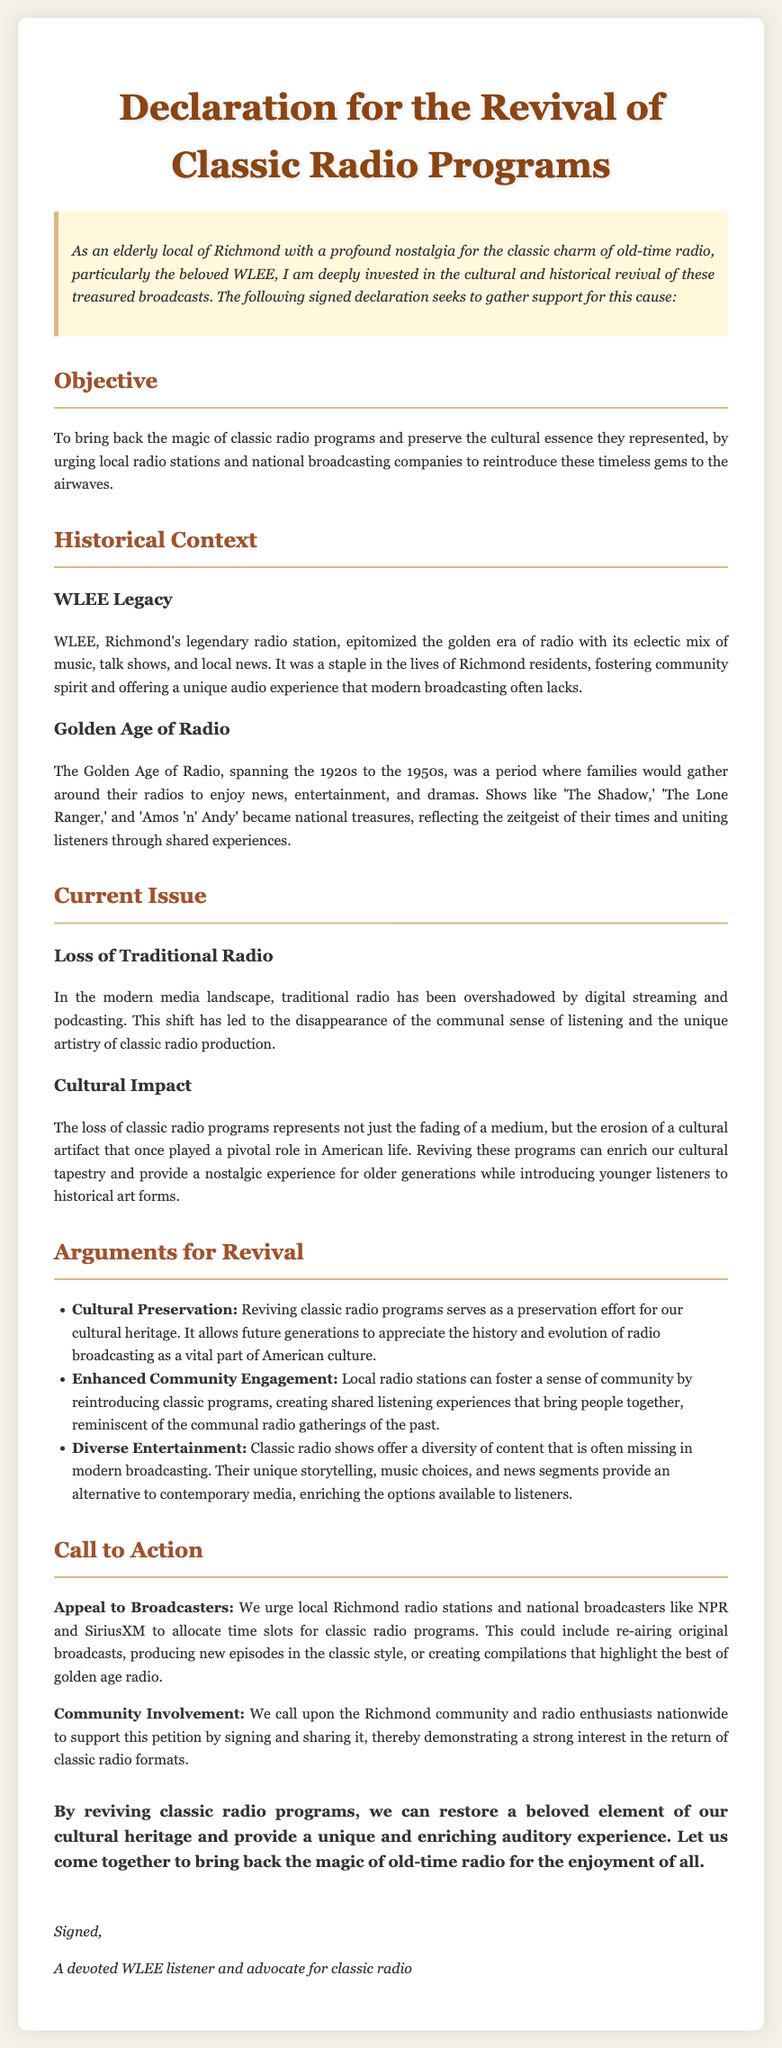What is the title of the document? The title of the document is presented at the top in a prominent format.
Answer: Declaration for the Revival of Classic Radio Programs Who is the intended audience for the call to action? The document appeals to local Richmond radio stations and national broadcasters.
Answer: Broadcasters What period is referred to as the Golden Age of Radio? The document specifies the time span known as the Golden Age of Radio.
Answer: 1920s to the 1950s What radio station is specifically mentioned in the historical context? The historical context includes a specific example of a radio station that is significant to Richmond locals.
Answer: WLEE What is one of the proposed actions for local radio stations? The document suggests a specific action for local radio stations to take to support the revival of classic radio.
Answer: Allocate time slots What does the document argue about the impact of losing traditional radio? The document mentions a specific cultural consequence of losing traditional radio programs.
Answer: Erosion of a cultural artifact What type of community engagement is encouraged in the document? The document calls for a specific type of community participation relating to the petition.
Answer: Community involvement What emotion does the introduction express regarding classic radio? The introduction conveys a specific feeling about old-time radio.
Answer: Nostalgia 